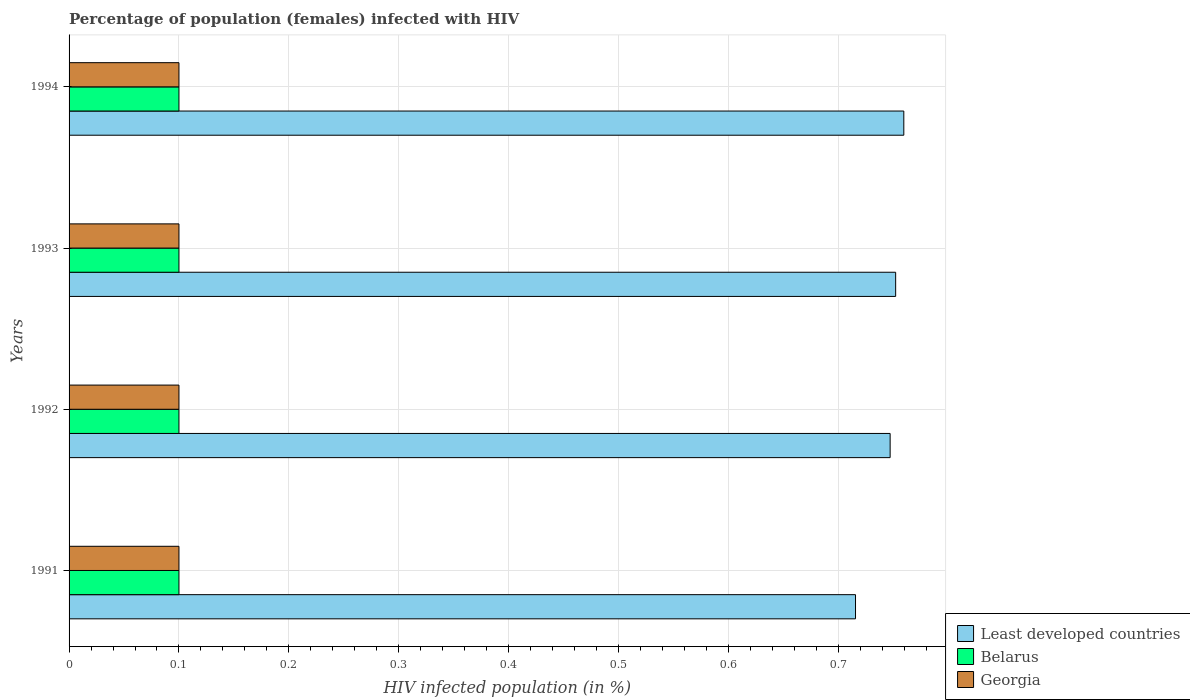How many different coloured bars are there?
Make the answer very short. 3. How many groups of bars are there?
Give a very brief answer. 4. Are the number of bars per tick equal to the number of legend labels?
Make the answer very short. Yes. Are the number of bars on each tick of the Y-axis equal?
Give a very brief answer. Yes. How many bars are there on the 2nd tick from the top?
Offer a terse response. 3. How many bars are there on the 1st tick from the bottom?
Your answer should be very brief. 3. What is the label of the 4th group of bars from the top?
Offer a terse response. 1991. In how many cases, is the number of bars for a given year not equal to the number of legend labels?
Offer a very short reply. 0. What is the percentage of HIV infected female population in Least developed countries in 1994?
Ensure brevity in your answer.  0.76. Across all years, what is the maximum percentage of HIV infected female population in Belarus?
Your answer should be compact. 0.1. In which year was the percentage of HIV infected female population in Least developed countries maximum?
Keep it short and to the point. 1994. What is the difference between the percentage of HIV infected female population in Belarus in 1994 and the percentage of HIV infected female population in Georgia in 1992?
Keep it short and to the point. 0. In the year 1991, what is the difference between the percentage of HIV infected female population in Georgia and percentage of HIV infected female population in Least developed countries?
Provide a succinct answer. -0.62. Is the percentage of HIV infected female population in Georgia in 1992 less than that in 1993?
Offer a very short reply. No. What is the difference between the highest and the lowest percentage of HIV infected female population in Belarus?
Your response must be concise. 0. What does the 3rd bar from the top in 1992 represents?
Provide a short and direct response. Least developed countries. What does the 2nd bar from the bottom in 1992 represents?
Keep it short and to the point. Belarus. Is it the case that in every year, the sum of the percentage of HIV infected female population in Least developed countries and percentage of HIV infected female population in Belarus is greater than the percentage of HIV infected female population in Georgia?
Your answer should be compact. Yes. How many bars are there?
Provide a succinct answer. 12. What is the difference between two consecutive major ticks on the X-axis?
Provide a short and direct response. 0.1. Are the values on the major ticks of X-axis written in scientific E-notation?
Make the answer very short. No. Does the graph contain any zero values?
Offer a terse response. No. How many legend labels are there?
Provide a succinct answer. 3. How are the legend labels stacked?
Your response must be concise. Vertical. What is the title of the graph?
Offer a very short reply. Percentage of population (females) infected with HIV. Does "Finland" appear as one of the legend labels in the graph?
Offer a very short reply. No. What is the label or title of the X-axis?
Ensure brevity in your answer.  HIV infected population (in %). What is the label or title of the Y-axis?
Provide a short and direct response. Years. What is the HIV infected population (in %) in Least developed countries in 1991?
Offer a terse response. 0.72. What is the HIV infected population (in %) of Least developed countries in 1992?
Give a very brief answer. 0.75. What is the HIV infected population (in %) in Belarus in 1992?
Keep it short and to the point. 0.1. What is the HIV infected population (in %) of Least developed countries in 1993?
Provide a short and direct response. 0.75. What is the HIV infected population (in %) in Belarus in 1993?
Make the answer very short. 0.1. What is the HIV infected population (in %) in Georgia in 1993?
Ensure brevity in your answer.  0.1. What is the HIV infected population (in %) in Least developed countries in 1994?
Your answer should be very brief. 0.76. What is the HIV infected population (in %) in Belarus in 1994?
Give a very brief answer. 0.1. What is the HIV infected population (in %) of Georgia in 1994?
Offer a very short reply. 0.1. Across all years, what is the maximum HIV infected population (in %) of Least developed countries?
Offer a very short reply. 0.76. Across all years, what is the maximum HIV infected population (in %) of Belarus?
Offer a terse response. 0.1. Across all years, what is the maximum HIV infected population (in %) of Georgia?
Offer a terse response. 0.1. Across all years, what is the minimum HIV infected population (in %) of Least developed countries?
Your answer should be very brief. 0.72. What is the total HIV infected population (in %) of Least developed countries in the graph?
Offer a terse response. 2.97. What is the difference between the HIV infected population (in %) of Least developed countries in 1991 and that in 1992?
Make the answer very short. -0.03. What is the difference between the HIV infected population (in %) of Belarus in 1991 and that in 1992?
Your answer should be compact. 0. What is the difference between the HIV infected population (in %) in Georgia in 1991 and that in 1992?
Give a very brief answer. 0. What is the difference between the HIV infected population (in %) in Least developed countries in 1991 and that in 1993?
Your answer should be very brief. -0.04. What is the difference between the HIV infected population (in %) of Belarus in 1991 and that in 1993?
Your answer should be compact. 0. What is the difference between the HIV infected population (in %) of Least developed countries in 1991 and that in 1994?
Make the answer very short. -0.04. What is the difference between the HIV infected population (in %) in Least developed countries in 1992 and that in 1993?
Give a very brief answer. -0.01. What is the difference between the HIV infected population (in %) of Least developed countries in 1992 and that in 1994?
Keep it short and to the point. -0.01. What is the difference between the HIV infected population (in %) of Georgia in 1992 and that in 1994?
Ensure brevity in your answer.  0. What is the difference between the HIV infected population (in %) of Least developed countries in 1993 and that in 1994?
Ensure brevity in your answer.  -0.01. What is the difference between the HIV infected population (in %) of Least developed countries in 1991 and the HIV infected population (in %) of Belarus in 1992?
Give a very brief answer. 0.62. What is the difference between the HIV infected population (in %) in Least developed countries in 1991 and the HIV infected population (in %) in Georgia in 1992?
Your answer should be compact. 0.62. What is the difference between the HIV infected population (in %) of Belarus in 1991 and the HIV infected population (in %) of Georgia in 1992?
Your answer should be compact. 0. What is the difference between the HIV infected population (in %) of Least developed countries in 1991 and the HIV infected population (in %) of Belarus in 1993?
Offer a terse response. 0.62. What is the difference between the HIV infected population (in %) of Least developed countries in 1991 and the HIV infected population (in %) of Georgia in 1993?
Your answer should be compact. 0.62. What is the difference between the HIV infected population (in %) in Least developed countries in 1991 and the HIV infected population (in %) in Belarus in 1994?
Ensure brevity in your answer.  0.62. What is the difference between the HIV infected population (in %) in Least developed countries in 1991 and the HIV infected population (in %) in Georgia in 1994?
Provide a short and direct response. 0.62. What is the difference between the HIV infected population (in %) in Least developed countries in 1992 and the HIV infected population (in %) in Belarus in 1993?
Your response must be concise. 0.65. What is the difference between the HIV infected population (in %) of Least developed countries in 1992 and the HIV infected population (in %) of Georgia in 1993?
Your answer should be very brief. 0.65. What is the difference between the HIV infected population (in %) in Belarus in 1992 and the HIV infected population (in %) in Georgia in 1993?
Give a very brief answer. 0. What is the difference between the HIV infected population (in %) of Least developed countries in 1992 and the HIV infected population (in %) of Belarus in 1994?
Your answer should be compact. 0.65. What is the difference between the HIV infected population (in %) in Least developed countries in 1992 and the HIV infected population (in %) in Georgia in 1994?
Your answer should be compact. 0.65. What is the difference between the HIV infected population (in %) in Belarus in 1992 and the HIV infected population (in %) in Georgia in 1994?
Provide a succinct answer. 0. What is the difference between the HIV infected population (in %) in Least developed countries in 1993 and the HIV infected population (in %) in Belarus in 1994?
Make the answer very short. 0.65. What is the difference between the HIV infected population (in %) of Least developed countries in 1993 and the HIV infected population (in %) of Georgia in 1994?
Your answer should be very brief. 0.65. What is the average HIV infected population (in %) in Least developed countries per year?
Your answer should be compact. 0.74. What is the average HIV infected population (in %) in Belarus per year?
Give a very brief answer. 0.1. In the year 1991, what is the difference between the HIV infected population (in %) in Least developed countries and HIV infected population (in %) in Belarus?
Your answer should be very brief. 0.62. In the year 1991, what is the difference between the HIV infected population (in %) in Least developed countries and HIV infected population (in %) in Georgia?
Your answer should be compact. 0.62. In the year 1992, what is the difference between the HIV infected population (in %) of Least developed countries and HIV infected population (in %) of Belarus?
Make the answer very short. 0.65. In the year 1992, what is the difference between the HIV infected population (in %) of Least developed countries and HIV infected population (in %) of Georgia?
Give a very brief answer. 0.65. In the year 1993, what is the difference between the HIV infected population (in %) in Least developed countries and HIV infected population (in %) in Belarus?
Keep it short and to the point. 0.65. In the year 1993, what is the difference between the HIV infected population (in %) of Least developed countries and HIV infected population (in %) of Georgia?
Your response must be concise. 0.65. In the year 1994, what is the difference between the HIV infected population (in %) in Least developed countries and HIV infected population (in %) in Belarus?
Your answer should be very brief. 0.66. In the year 1994, what is the difference between the HIV infected population (in %) of Least developed countries and HIV infected population (in %) of Georgia?
Provide a short and direct response. 0.66. In the year 1994, what is the difference between the HIV infected population (in %) of Belarus and HIV infected population (in %) of Georgia?
Your answer should be very brief. 0. What is the ratio of the HIV infected population (in %) of Least developed countries in 1991 to that in 1992?
Provide a succinct answer. 0.96. What is the ratio of the HIV infected population (in %) of Least developed countries in 1991 to that in 1993?
Keep it short and to the point. 0.95. What is the ratio of the HIV infected population (in %) of Belarus in 1991 to that in 1993?
Give a very brief answer. 1. What is the ratio of the HIV infected population (in %) in Least developed countries in 1991 to that in 1994?
Your answer should be very brief. 0.94. What is the ratio of the HIV infected population (in %) in Belarus in 1992 to that in 1993?
Ensure brevity in your answer.  1. What is the ratio of the HIV infected population (in %) of Least developed countries in 1992 to that in 1994?
Make the answer very short. 0.98. What is the ratio of the HIV infected population (in %) of Georgia in 1992 to that in 1994?
Give a very brief answer. 1. What is the ratio of the HIV infected population (in %) in Least developed countries in 1993 to that in 1994?
Offer a terse response. 0.99. What is the difference between the highest and the second highest HIV infected population (in %) in Least developed countries?
Provide a short and direct response. 0.01. What is the difference between the highest and the lowest HIV infected population (in %) in Least developed countries?
Provide a succinct answer. 0.04. What is the difference between the highest and the lowest HIV infected population (in %) of Georgia?
Make the answer very short. 0. 